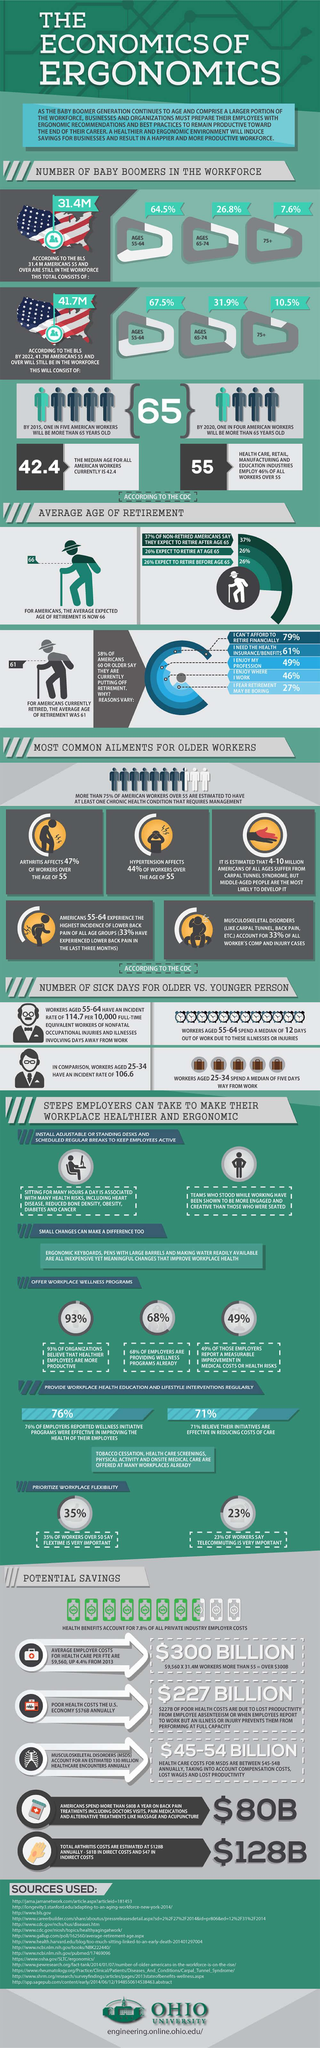Specify some key components in this picture. According to a recent survey, 26% of Americans expect to retire before the age of 65. According to the data, 68% of employers are providing health schemes to their employees. According to the data, a staggering 99.4% of individuals below the age of 75 are still actively participating in the US workforce. According to data, approximately 64.5% of individuals under the age of 65 are currently part of the US workforce. 